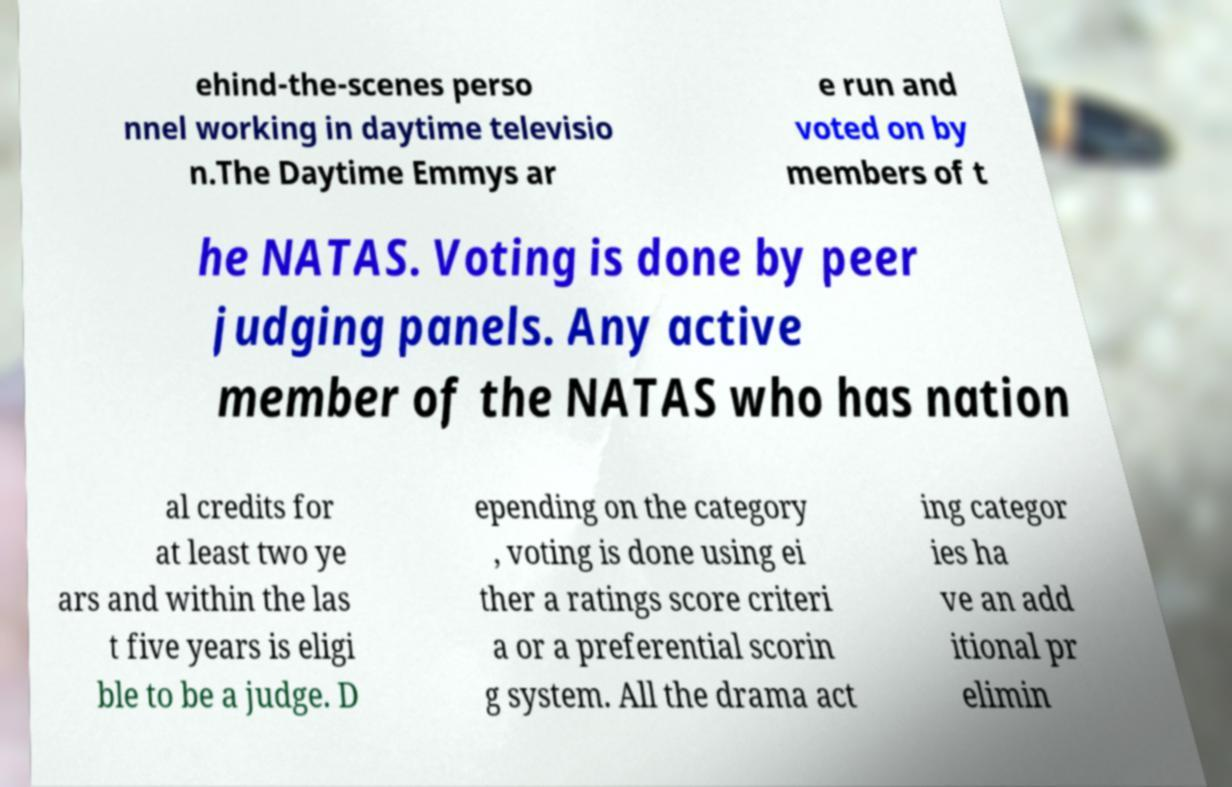Could you assist in decoding the text presented in this image and type it out clearly? ehind-the-scenes perso nnel working in daytime televisio n.The Daytime Emmys ar e run and voted on by members of t he NATAS. Voting is done by peer judging panels. Any active member of the NATAS who has nation al credits for at least two ye ars and within the las t five years is eligi ble to be a judge. D epending on the category , voting is done using ei ther a ratings score criteri a or a preferential scorin g system. All the drama act ing categor ies ha ve an add itional pr elimin 